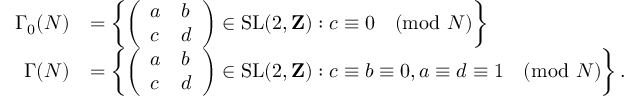Convert formula to latex. <formula><loc_0><loc_0><loc_500><loc_500>{ \begin{array} { r l } { \Gamma _ { 0 } ( N ) } & { = \left \{ { \left ( \begin{array} { l l } { a } & { b } \\ { c } & { d } \end{array} \right ) } \in { S L } ( 2 , Z ) \colon c \equiv 0 { \pmod { N } } \right \} } \\ { \Gamma ( N ) } & { = \left \{ { \left ( \begin{array} { l l } { a } & { b } \\ { c } & { d } \end{array} \right ) } \in { S L } ( 2 , Z ) \colon c \equiv b \equiv 0 , a \equiv d \equiv 1 { \pmod { N } } \right \} . } \end{array} }</formula> 